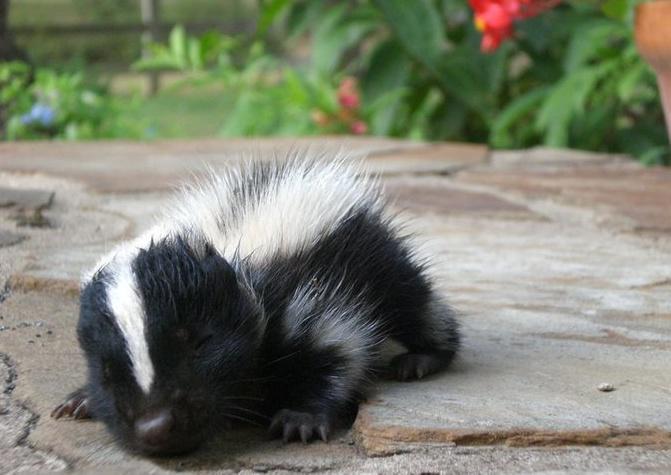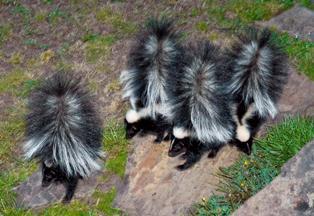The first image is the image on the left, the second image is the image on the right. Analyze the images presented: Is the assertion "There are more than two skunks in total." valid? Answer yes or no. Yes. The first image is the image on the left, the second image is the image on the right. Given the left and right images, does the statement "The right image includes at least two somewhat forward-angled side-by-side skunks with their tails up." hold true? Answer yes or no. Yes. 